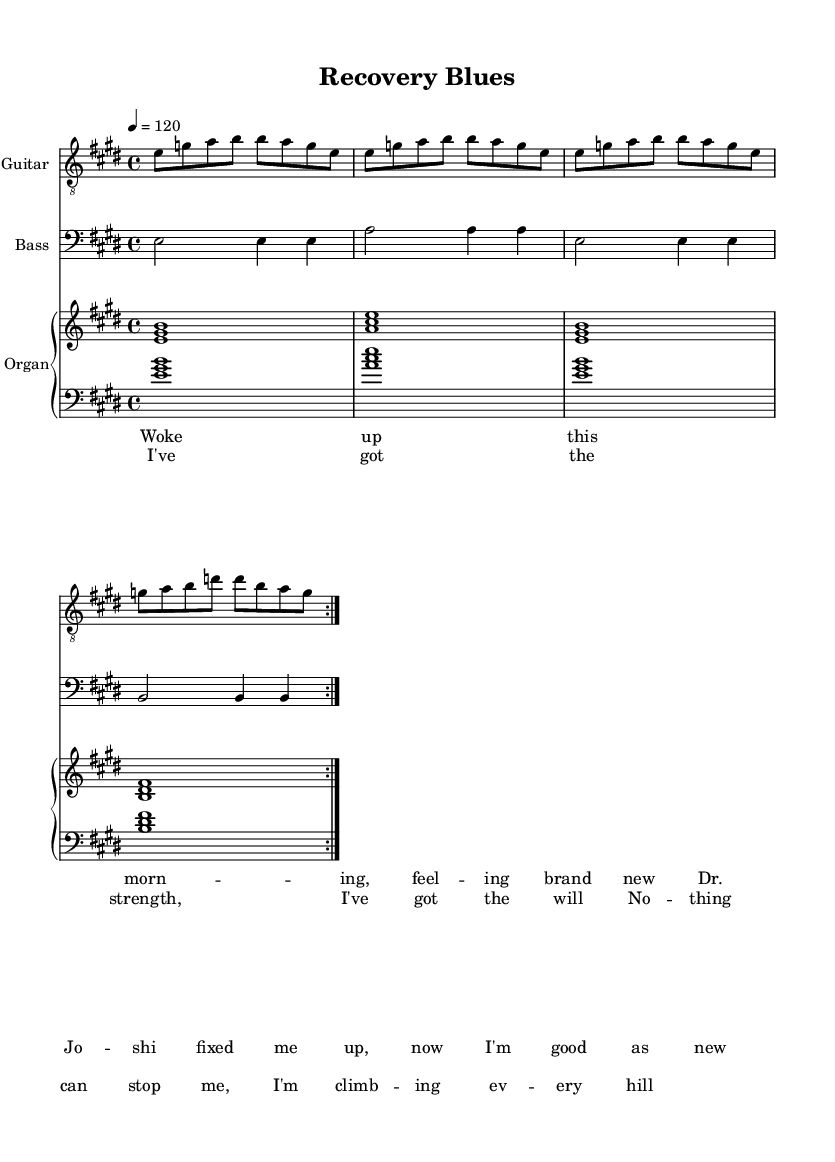What is the key signature of this music? The key signature is E major, which has four sharps: F#, C#, G#, and D#. These can be identified at the beginning of the staff in the key signature section.
Answer: E major What is the time signature of the piece? The time signature is 4/4, which can be found at the beginning of the sheet music right after the key signature. This means there are four beats in a measure and the quarter note gets one beat.
Answer: 4/4 What is the tempo marking for this composition? The tempo marking is 120, indicated by "4 = 120" in the tempo instruction. This means the quarter note is played at a speed of 120 beats per minute.
Answer: 120 How many times is the main guitar motif repeated? The main guitar motif is repeated 2 times, as indicated by the \repeat volta 2 instruction in the guitar part. This signifies that the section should be played twice.
Answer: 2 What emotion or theme does the chorus convey? The chorus conveys a theme of strength and resilience, as expressed in the lyrics: "I've got the strength, I've got the will, nothing can stop me, I'm climbing every hill." This theme is central to the electric blues genre, highlighting personal empowerment.
Answer: Strength and resilience What type of musical piece is this? This is an electric blues piece. The characteristics include its use of the twelve-bar blues structure, electric instrumentation, and themes of personal strength, which are common in electric blues themes.
Answer: Electric blues 